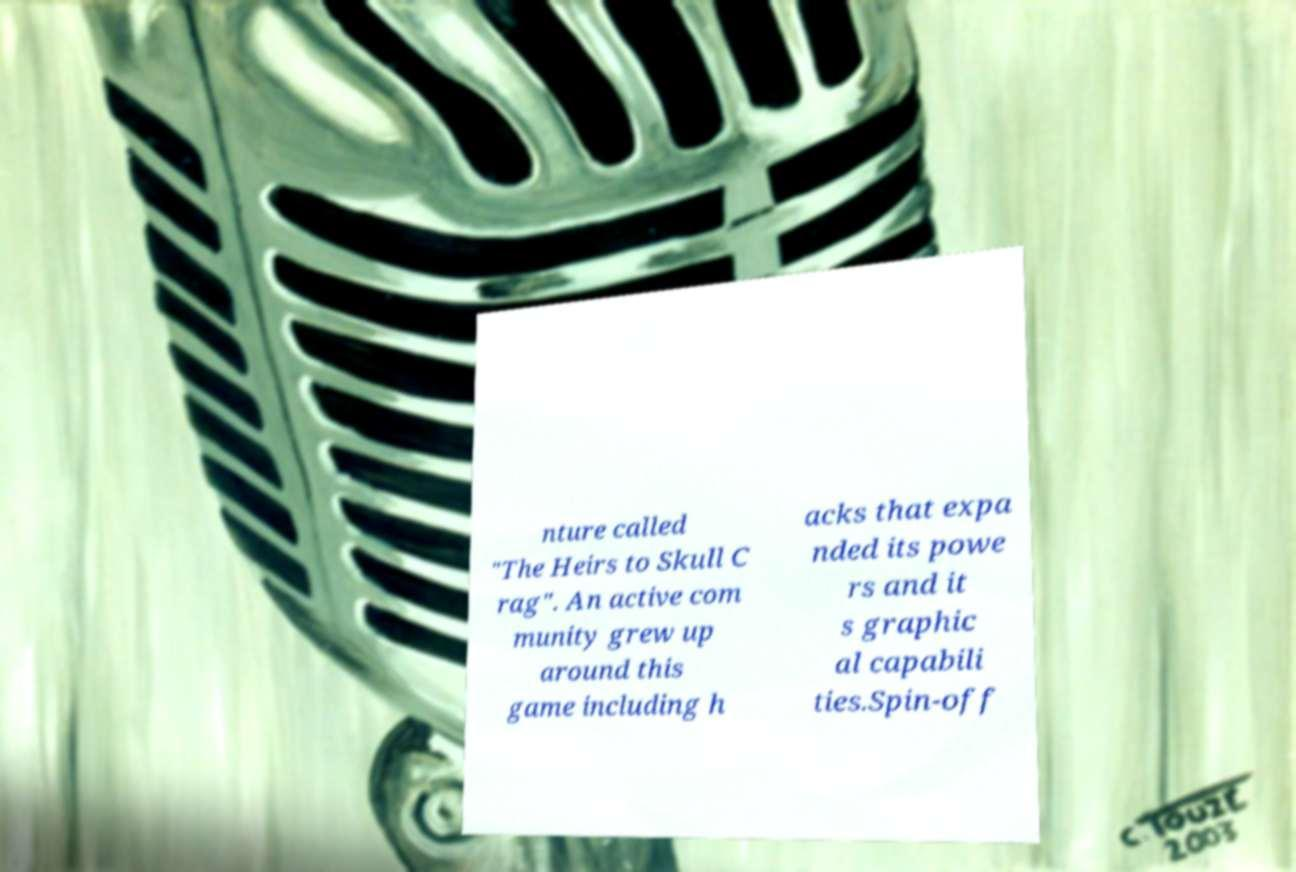Can you accurately transcribe the text from the provided image for me? nture called "The Heirs to Skull C rag". An active com munity grew up around this game including h acks that expa nded its powe rs and it s graphic al capabili ties.Spin-off 